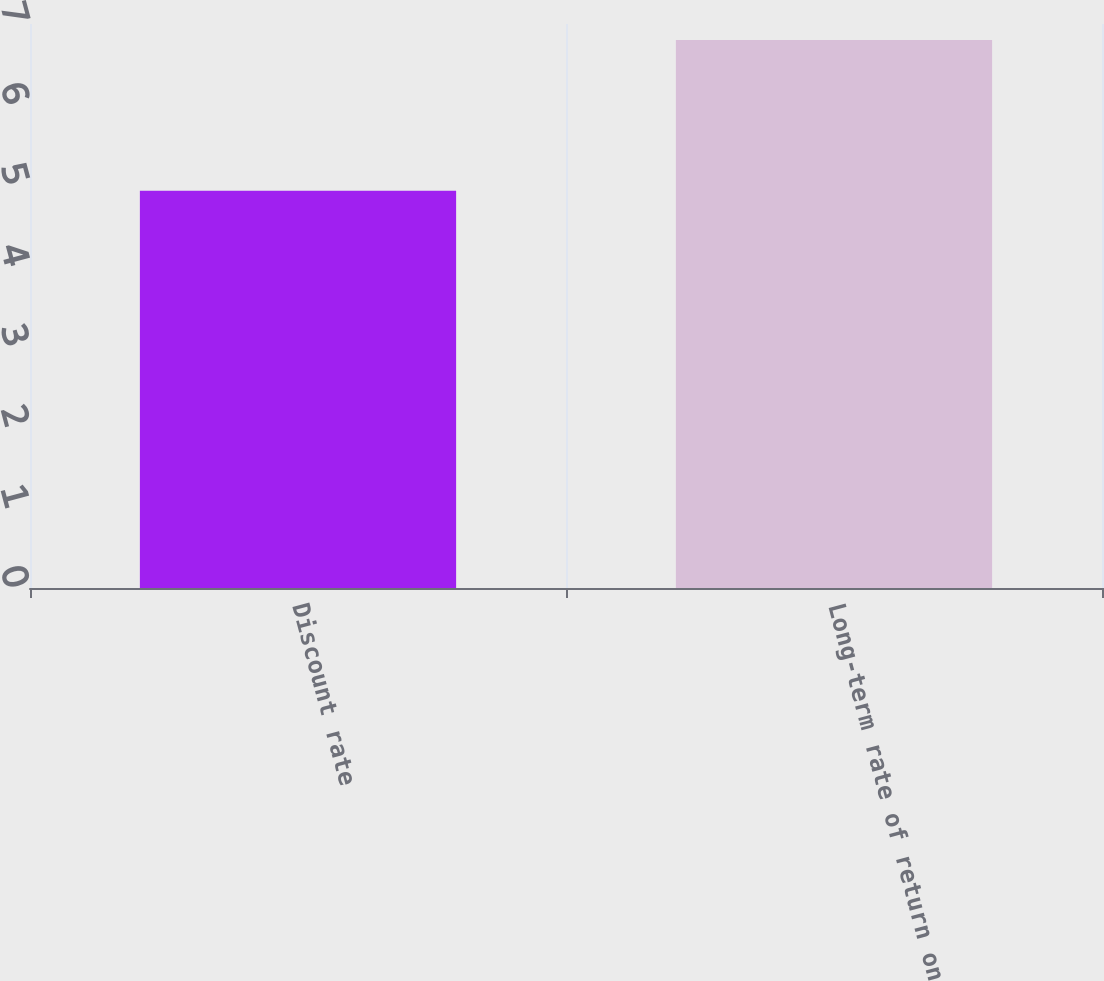Convert chart to OTSL. <chart><loc_0><loc_0><loc_500><loc_500><bar_chart><fcel>Discount rate<fcel>Long-term rate of return on<nl><fcel>4.93<fcel>6.8<nl></chart> 